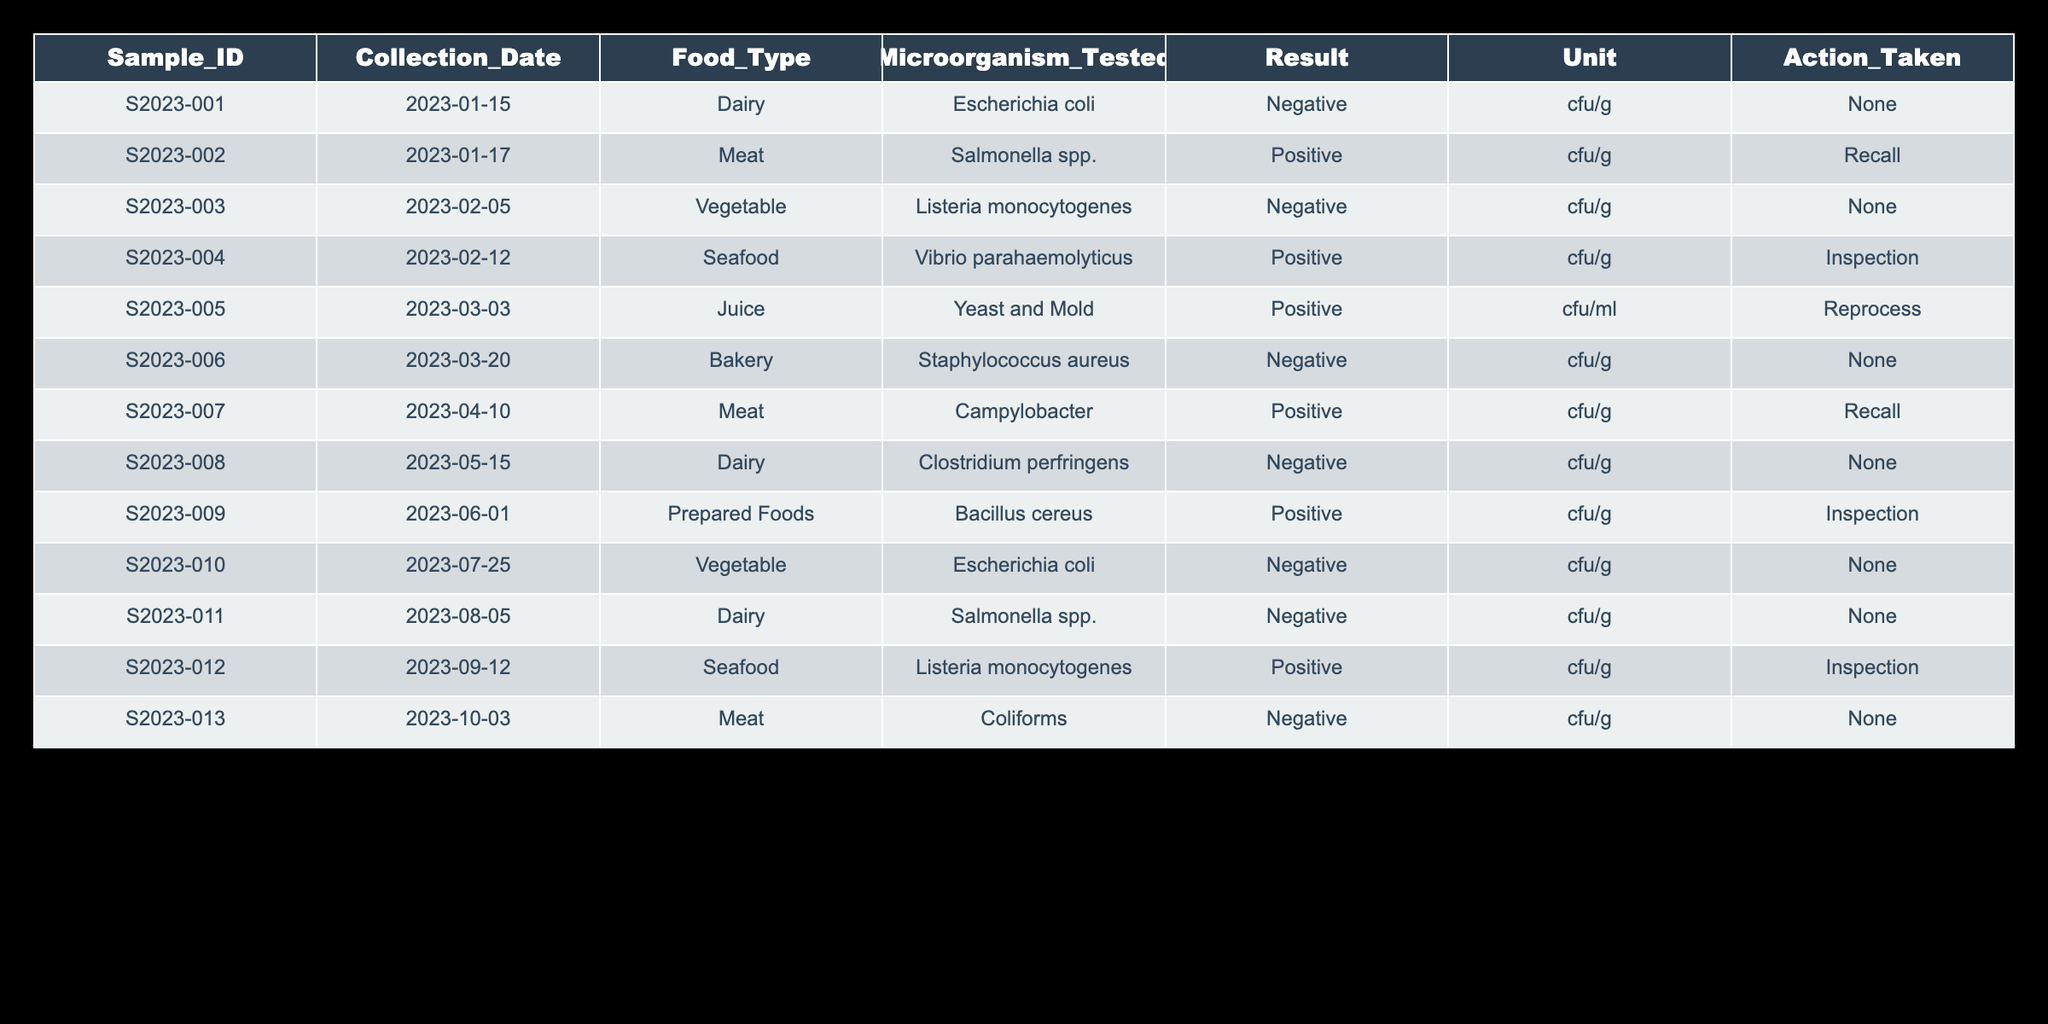What is the result of the sample collected on January 17, 2023? The sample collected on January 17, 2023, is S2023-002, which tested for Salmonella spp. The result is positive.
Answer: Positive How many food samples tested positive for microorganisms? To find this, we count the rows where the Result column lists "Positive." There are 5 samples with positive results: S2023-002, S2023-004, S2023-005, S2023-007, and S2023-012.
Answer: 5 Did any dairy samples test positive for microorganisms? By checking the Food_Type column for Dairy and looking at the corresponding results, we see that only S2023-001 (Negative) and S2023-011 (Negative) were collected in the Dairy category. Therefore, there were no positive tests for dairy samples.
Answer: No Which food types had a positive test result for Listeria monocytogenes? We need to find the rows in the table where the Microorganism_Tested is Listeria monocytogenes and check the Food_Type. Only S2023-003 (Vegetable) and S2023-012 (Seafood) had positive results. Thus, the food types are Vegetable and Seafood.
Answer: Vegetable, Seafood What actions were taken for the samples that tested positive for Salmonella spp.? There were two samples tested for Salmonella spp.: S2023-002 (positive result) with an action of Recall and S2023-011 (negative result). Since we only consider the positive result, the action taken is Recall.
Answer: Recall What percentage of total collected samples tested negative? There are a total of 13 samples. The count of negative results is 8 (S2023-001, S2023-003, S2023-006, S2023-008, S2023-010, S2023-011, S2023-013). To find the percentage, we do (8/13) * 100 = 61.54%.
Answer: 61.54% Which food type had the least number of positive tests? To find the food type with the least positive tests, we look at all positive results and count them based on food type. Salmonella spp. from Meat has one positive (S2023-002). The same is true for Listeria monocytogenes, which has one positive from Seafood (S2023-012). Other types have either no positives or more than one. There are thus 2 types with the least positives: Meat and Seafood.
Answer: Meat, Seafood How many samples were collected in each month? We can analyze the Collection_Date column and group the samples by month. For January, there are 2 samples; February has 2; March has 2; April has 1; May has 1; June has 1; August has 1; September has 1; and October has 1. The counts are: January (2), February (2), March (2), April (1), May (1), June (1), August (1), September (1), October (1).
Answer: Varies: Jan (2), Feb (2), Mar (2), Apr (1), May (1), Jun (1), Aug (1), Sep (1), Oct (1) 